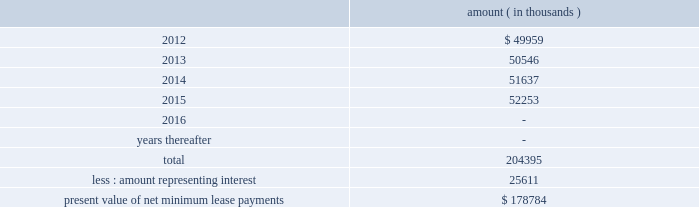Entergy corporation and subsidiaries notes to financial statements ferc audit report , system energy initially recorded as a net regulatory asset the difference between the recovery of the lease payments and the amounts expensed for interest and depreciation and continues to record this difference as a regulatory asset or liability on an ongoing basis , resulting in a zero net balance for the regulatory asset at the end of the lease term .
The amount was a net regulatory asset ( liability ) of ( $ 2.0 ) million and $ 60.6 million as of december 31 , 2011 and 2010 , respectively .
As of december 31 , 2011 , system energy had future minimum lease payments ( reflecting an implicit rate of 5.13% ( 5.13 % ) ) , which are recorded as long-term debt as follows : amount ( in thousands ) .

What portion of the future minimum lease payments is expected to be paid within the next 12 months? 
Computations: (49959 / 204395)
Answer: 0.24442. 